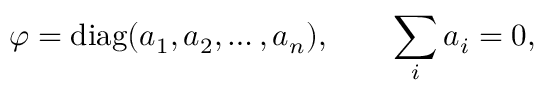<formula> <loc_0><loc_0><loc_500><loc_500>\varphi = d i a g ( a _ { 1 } , a _ { 2 } , \dots , a _ { n } ) , \quad \sum _ { i } a _ { i } = 0 ,</formula> 